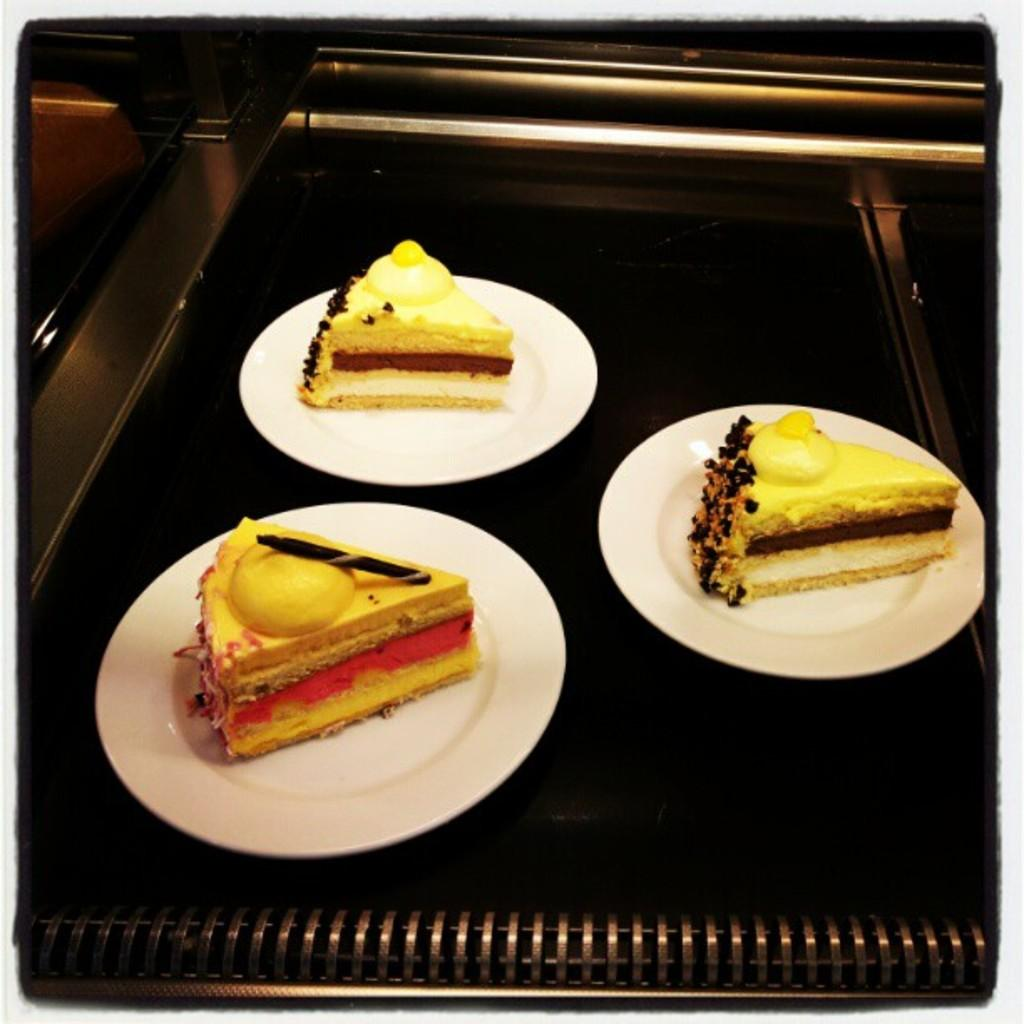What type of food can be seen in the image? There are pastries in the image. How are the pastries arranged or displayed? The pastries are on plates in the image. What other object is present in the image besides the pastries? There is a machine in the image. What type of hat is the machine wearing in the image? There is no hat present in the image, as the machine is not wearing any clothing or accessories. 